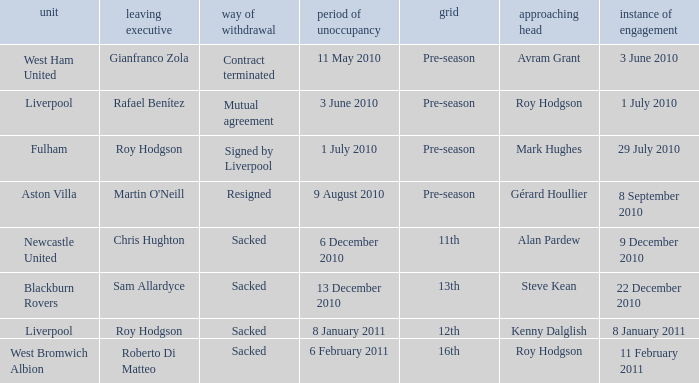How many incoming managers were there after Roy Hodgson left the position for the Fulham team? 1.0. 